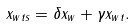Convert formula to latex. <formula><loc_0><loc_0><loc_500><loc_500>x _ { w t s } = \delta x _ { w } + \gamma x _ { w t } .</formula> 